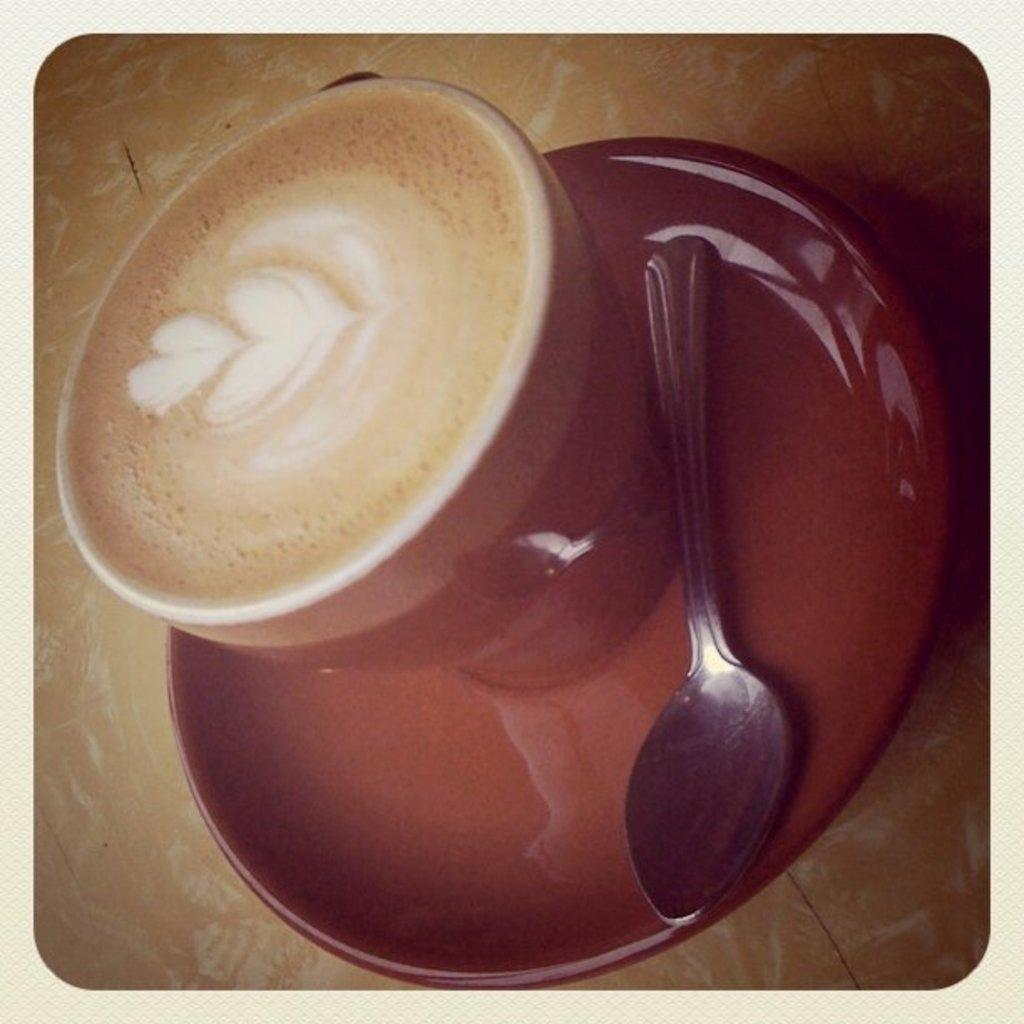What color is the cup that is visible in the image? There is a red color cup in the image. What is the cup associated with in the image? There is a saucer associated with the cup. What is inside the cup in the image? There is coffee in the cup. What utensil is present in the saucer in the image? There is a spoon in the saucer. Can you see an airplane flying in the image? There is no airplane visible in the image. Is there a fight happening between two people in the image? There is no fight or any indication of conflict in the image. What type of pie is being served on a plate in the image? There is no pie present in the image. 